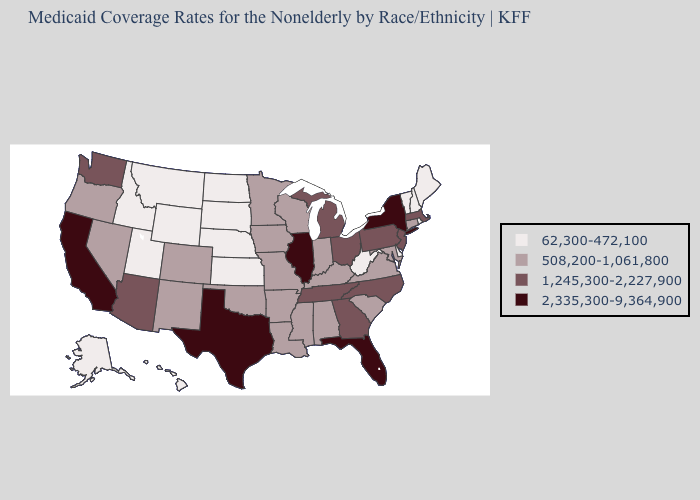What is the value of Arizona?
Keep it brief. 1,245,300-2,227,900. What is the highest value in states that border West Virginia?
Quick response, please. 1,245,300-2,227,900. What is the value of Delaware?
Write a very short answer. 62,300-472,100. Name the states that have a value in the range 1,245,300-2,227,900?
Be succinct. Arizona, Georgia, Massachusetts, Michigan, New Jersey, North Carolina, Ohio, Pennsylvania, Tennessee, Washington. Among the states that border California , which have the highest value?
Give a very brief answer. Arizona. Name the states that have a value in the range 508,200-1,061,800?
Write a very short answer. Alabama, Arkansas, Colorado, Connecticut, Indiana, Iowa, Kentucky, Louisiana, Maryland, Minnesota, Mississippi, Missouri, Nevada, New Mexico, Oklahoma, Oregon, South Carolina, Virginia, Wisconsin. Name the states that have a value in the range 1,245,300-2,227,900?
Keep it brief. Arizona, Georgia, Massachusetts, Michigan, New Jersey, North Carolina, Ohio, Pennsylvania, Tennessee, Washington. What is the value of Maine?
Answer briefly. 62,300-472,100. Does the map have missing data?
Answer briefly. No. Which states have the lowest value in the Northeast?
Give a very brief answer. Maine, New Hampshire, Rhode Island, Vermont. Among the states that border Nevada , which have the highest value?
Concise answer only. California. Name the states that have a value in the range 2,335,300-9,364,900?
Concise answer only. California, Florida, Illinois, New York, Texas. What is the value of Iowa?
Answer briefly. 508,200-1,061,800. What is the highest value in the MidWest ?
Concise answer only. 2,335,300-9,364,900. 